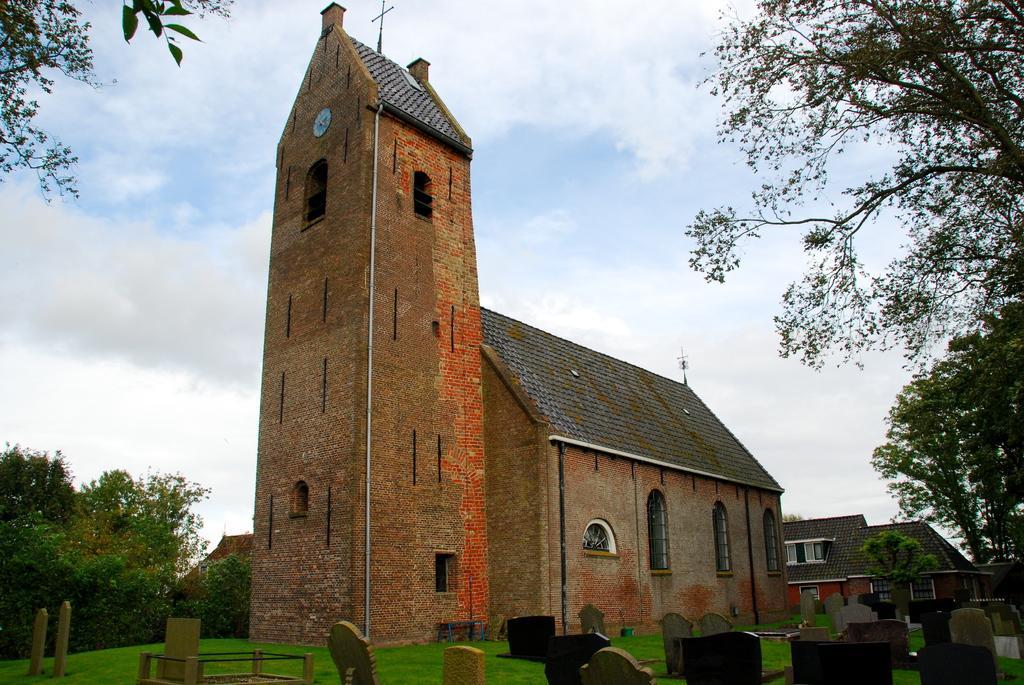Could you give a brief overview of what you see in this image? This place is seems to be a graveyard. In the middle of the image there are few buildings. On the right and left side of the image there are trees. On the ground, I can see the grass. At the top of the image I can see the sky and clouds. 